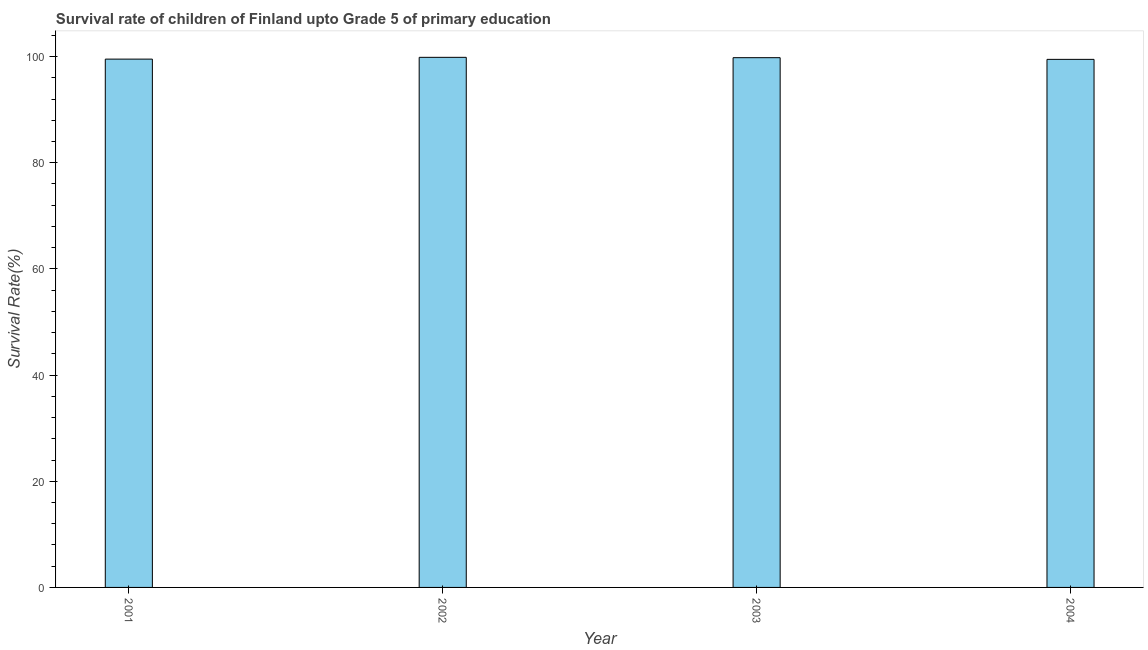Does the graph contain any zero values?
Make the answer very short. No. Does the graph contain grids?
Offer a very short reply. No. What is the title of the graph?
Offer a very short reply. Survival rate of children of Finland upto Grade 5 of primary education. What is the label or title of the Y-axis?
Offer a very short reply. Survival Rate(%). What is the survival rate in 2004?
Provide a short and direct response. 99.48. Across all years, what is the maximum survival rate?
Your answer should be compact. 99.86. Across all years, what is the minimum survival rate?
Ensure brevity in your answer.  99.48. In which year was the survival rate maximum?
Offer a very short reply. 2002. In which year was the survival rate minimum?
Offer a very short reply. 2004. What is the sum of the survival rate?
Offer a very short reply. 398.66. What is the difference between the survival rate in 2002 and 2004?
Offer a terse response. 0.39. What is the average survival rate per year?
Make the answer very short. 99.67. What is the median survival rate?
Provide a succinct answer. 99.66. Is the survival rate in 2001 less than that in 2002?
Offer a terse response. Yes. What is the difference between the highest and the second highest survival rate?
Provide a short and direct response. 0.07. What is the difference between the highest and the lowest survival rate?
Provide a short and direct response. 0.39. In how many years, is the survival rate greater than the average survival rate taken over all years?
Provide a short and direct response. 2. Are all the bars in the graph horizontal?
Offer a terse response. No. What is the Survival Rate(%) of 2001?
Provide a succinct answer. 99.53. What is the Survival Rate(%) of 2002?
Ensure brevity in your answer.  99.86. What is the Survival Rate(%) in 2003?
Your response must be concise. 99.8. What is the Survival Rate(%) of 2004?
Offer a very short reply. 99.48. What is the difference between the Survival Rate(%) in 2001 and 2002?
Make the answer very short. -0.34. What is the difference between the Survival Rate(%) in 2001 and 2003?
Offer a terse response. -0.27. What is the difference between the Survival Rate(%) in 2001 and 2004?
Your response must be concise. 0.05. What is the difference between the Survival Rate(%) in 2002 and 2003?
Your answer should be very brief. 0.07. What is the difference between the Survival Rate(%) in 2002 and 2004?
Provide a succinct answer. 0.39. What is the difference between the Survival Rate(%) in 2003 and 2004?
Provide a short and direct response. 0.32. What is the ratio of the Survival Rate(%) in 2001 to that in 2002?
Ensure brevity in your answer.  1. 